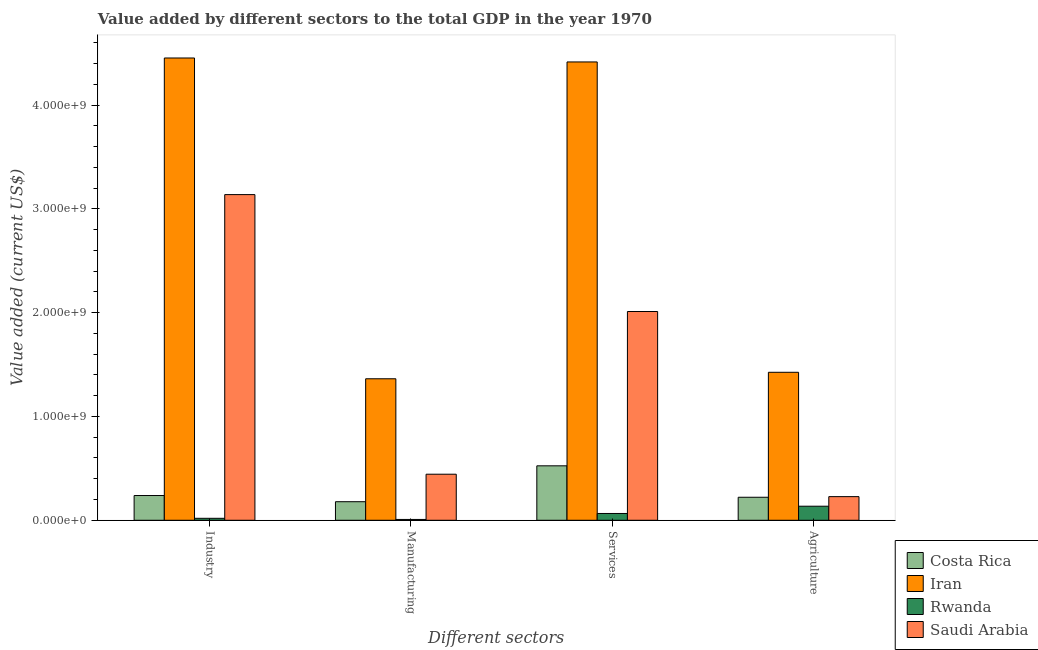How many different coloured bars are there?
Offer a terse response. 4. How many groups of bars are there?
Offer a very short reply. 4. Are the number of bars on each tick of the X-axis equal?
Give a very brief answer. Yes. How many bars are there on the 2nd tick from the left?
Make the answer very short. 4. How many bars are there on the 2nd tick from the right?
Ensure brevity in your answer.  4. What is the label of the 2nd group of bars from the left?
Make the answer very short. Manufacturing. What is the value added by services sector in Iran?
Your answer should be compact. 4.42e+09. Across all countries, what is the maximum value added by agricultural sector?
Your answer should be very brief. 1.43e+09. Across all countries, what is the minimum value added by manufacturing sector?
Ensure brevity in your answer.  7.90e+06. In which country was the value added by industrial sector maximum?
Make the answer very short. Iran. In which country was the value added by manufacturing sector minimum?
Provide a succinct answer. Rwanda. What is the total value added by services sector in the graph?
Offer a very short reply. 7.02e+09. What is the difference between the value added by manufacturing sector in Rwanda and that in Costa Rica?
Your response must be concise. -1.71e+08. What is the difference between the value added by agricultural sector in Costa Rica and the value added by manufacturing sector in Rwanda?
Offer a very short reply. 2.14e+08. What is the average value added by manufacturing sector per country?
Your response must be concise. 4.98e+08. What is the difference between the value added by manufacturing sector and value added by services sector in Costa Rica?
Give a very brief answer. -3.46e+08. In how many countries, is the value added by industrial sector greater than 3800000000 US$?
Give a very brief answer. 1. What is the ratio of the value added by agricultural sector in Costa Rica to that in Iran?
Your response must be concise. 0.16. Is the value added by services sector in Iran less than that in Rwanda?
Ensure brevity in your answer.  No. What is the difference between the highest and the second highest value added by services sector?
Provide a succinct answer. 2.40e+09. What is the difference between the highest and the lowest value added by industrial sector?
Provide a succinct answer. 4.44e+09. In how many countries, is the value added by services sector greater than the average value added by services sector taken over all countries?
Keep it short and to the point. 2. Is it the case that in every country, the sum of the value added by manufacturing sector and value added by industrial sector is greater than the sum of value added by agricultural sector and value added by services sector?
Give a very brief answer. No. What does the 3rd bar from the left in Manufacturing represents?
Keep it short and to the point. Rwanda. What does the 1st bar from the right in Manufacturing represents?
Your response must be concise. Saudi Arabia. How many bars are there?
Your answer should be very brief. 16. What is the difference between two consecutive major ticks on the Y-axis?
Your answer should be compact. 1.00e+09. Does the graph contain any zero values?
Give a very brief answer. No. Does the graph contain grids?
Your answer should be compact. No. How many legend labels are there?
Offer a terse response. 4. How are the legend labels stacked?
Make the answer very short. Vertical. What is the title of the graph?
Make the answer very short. Value added by different sectors to the total GDP in the year 1970. What is the label or title of the X-axis?
Offer a very short reply. Different sectors. What is the label or title of the Y-axis?
Your answer should be very brief. Value added (current US$). What is the Value added (current US$) in Costa Rica in Industry?
Provide a succinct answer. 2.38e+08. What is the Value added (current US$) in Iran in Industry?
Your answer should be very brief. 4.45e+09. What is the Value added (current US$) of Rwanda in Industry?
Provide a succinct answer. 1.89e+07. What is the Value added (current US$) of Saudi Arabia in Industry?
Your answer should be compact. 3.14e+09. What is the Value added (current US$) in Costa Rica in Manufacturing?
Keep it short and to the point. 1.79e+08. What is the Value added (current US$) of Iran in Manufacturing?
Your answer should be very brief. 1.36e+09. What is the Value added (current US$) of Rwanda in Manufacturing?
Give a very brief answer. 7.90e+06. What is the Value added (current US$) of Saudi Arabia in Manufacturing?
Offer a very short reply. 4.44e+08. What is the Value added (current US$) in Costa Rica in Services?
Offer a very short reply. 5.25e+08. What is the Value added (current US$) of Iran in Services?
Make the answer very short. 4.42e+09. What is the Value added (current US$) in Rwanda in Services?
Your answer should be compact. 6.55e+07. What is the Value added (current US$) of Saudi Arabia in Services?
Your answer should be very brief. 2.01e+09. What is the Value added (current US$) of Costa Rica in Agriculture?
Your response must be concise. 2.22e+08. What is the Value added (current US$) of Iran in Agriculture?
Provide a succinct answer. 1.43e+09. What is the Value added (current US$) in Rwanda in Agriculture?
Provide a short and direct response. 1.36e+08. What is the Value added (current US$) of Saudi Arabia in Agriculture?
Keep it short and to the point. 2.28e+08. Across all Different sectors, what is the maximum Value added (current US$) in Costa Rica?
Make the answer very short. 5.25e+08. Across all Different sectors, what is the maximum Value added (current US$) of Iran?
Ensure brevity in your answer.  4.45e+09. Across all Different sectors, what is the maximum Value added (current US$) in Rwanda?
Provide a short and direct response. 1.36e+08. Across all Different sectors, what is the maximum Value added (current US$) of Saudi Arabia?
Your answer should be compact. 3.14e+09. Across all Different sectors, what is the minimum Value added (current US$) in Costa Rica?
Your response must be concise. 1.79e+08. Across all Different sectors, what is the minimum Value added (current US$) of Iran?
Your answer should be very brief. 1.36e+09. Across all Different sectors, what is the minimum Value added (current US$) of Rwanda?
Keep it short and to the point. 7.90e+06. Across all Different sectors, what is the minimum Value added (current US$) of Saudi Arabia?
Your answer should be compact. 2.28e+08. What is the total Value added (current US$) of Costa Rica in the graph?
Your answer should be very brief. 1.16e+09. What is the total Value added (current US$) in Iran in the graph?
Your answer should be very brief. 1.17e+1. What is the total Value added (current US$) in Rwanda in the graph?
Offer a terse response. 2.28e+08. What is the total Value added (current US$) in Saudi Arabia in the graph?
Provide a short and direct response. 5.82e+09. What is the difference between the Value added (current US$) in Costa Rica in Industry and that in Manufacturing?
Your answer should be very brief. 5.95e+07. What is the difference between the Value added (current US$) in Iran in Industry and that in Manufacturing?
Offer a very short reply. 3.09e+09. What is the difference between the Value added (current US$) in Rwanda in Industry and that in Manufacturing?
Offer a terse response. 1.10e+07. What is the difference between the Value added (current US$) of Saudi Arabia in Industry and that in Manufacturing?
Your answer should be very brief. 2.69e+09. What is the difference between the Value added (current US$) in Costa Rica in Industry and that in Services?
Make the answer very short. -2.86e+08. What is the difference between the Value added (current US$) of Iran in Industry and that in Services?
Ensure brevity in your answer.  3.81e+07. What is the difference between the Value added (current US$) of Rwanda in Industry and that in Services?
Your answer should be compact. -4.66e+07. What is the difference between the Value added (current US$) in Saudi Arabia in Industry and that in Services?
Make the answer very short. 1.13e+09. What is the difference between the Value added (current US$) in Costa Rica in Industry and that in Agriculture?
Provide a short and direct response. 1.66e+07. What is the difference between the Value added (current US$) of Iran in Industry and that in Agriculture?
Provide a succinct answer. 3.03e+09. What is the difference between the Value added (current US$) of Rwanda in Industry and that in Agriculture?
Your answer should be compact. -1.17e+08. What is the difference between the Value added (current US$) of Saudi Arabia in Industry and that in Agriculture?
Make the answer very short. 2.91e+09. What is the difference between the Value added (current US$) in Costa Rica in Manufacturing and that in Services?
Make the answer very short. -3.46e+08. What is the difference between the Value added (current US$) in Iran in Manufacturing and that in Services?
Offer a terse response. -3.05e+09. What is the difference between the Value added (current US$) of Rwanda in Manufacturing and that in Services?
Your answer should be very brief. -5.76e+07. What is the difference between the Value added (current US$) in Saudi Arabia in Manufacturing and that in Services?
Provide a short and direct response. -1.57e+09. What is the difference between the Value added (current US$) in Costa Rica in Manufacturing and that in Agriculture?
Provide a short and direct response. -4.29e+07. What is the difference between the Value added (current US$) in Iran in Manufacturing and that in Agriculture?
Provide a short and direct response. -6.25e+07. What is the difference between the Value added (current US$) of Rwanda in Manufacturing and that in Agriculture?
Keep it short and to the point. -1.28e+08. What is the difference between the Value added (current US$) of Saudi Arabia in Manufacturing and that in Agriculture?
Make the answer very short. 2.16e+08. What is the difference between the Value added (current US$) of Costa Rica in Services and that in Agriculture?
Provide a short and direct response. 3.03e+08. What is the difference between the Value added (current US$) of Iran in Services and that in Agriculture?
Give a very brief answer. 2.99e+09. What is the difference between the Value added (current US$) of Rwanda in Services and that in Agriculture?
Keep it short and to the point. -7.00e+07. What is the difference between the Value added (current US$) of Saudi Arabia in Services and that in Agriculture?
Offer a terse response. 1.78e+09. What is the difference between the Value added (current US$) in Costa Rica in Industry and the Value added (current US$) in Iran in Manufacturing?
Ensure brevity in your answer.  -1.12e+09. What is the difference between the Value added (current US$) in Costa Rica in Industry and the Value added (current US$) in Rwanda in Manufacturing?
Offer a very short reply. 2.30e+08. What is the difference between the Value added (current US$) in Costa Rica in Industry and the Value added (current US$) in Saudi Arabia in Manufacturing?
Offer a terse response. -2.05e+08. What is the difference between the Value added (current US$) of Iran in Industry and the Value added (current US$) of Rwanda in Manufacturing?
Make the answer very short. 4.45e+09. What is the difference between the Value added (current US$) of Iran in Industry and the Value added (current US$) of Saudi Arabia in Manufacturing?
Give a very brief answer. 4.01e+09. What is the difference between the Value added (current US$) in Rwanda in Industry and the Value added (current US$) in Saudi Arabia in Manufacturing?
Give a very brief answer. -4.25e+08. What is the difference between the Value added (current US$) in Costa Rica in Industry and the Value added (current US$) in Iran in Services?
Offer a very short reply. -4.18e+09. What is the difference between the Value added (current US$) in Costa Rica in Industry and the Value added (current US$) in Rwanda in Services?
Provide a short and direct response. 1.73e+08. What is the difference between the Value added (current US$) of Costa Rica in Industry and the Value added (current US$) of Saudi Arabia in Services?
Provide a short and direct response. -1.77e+09. What is the difference between the Value added (current US$) in Iran in Industry and the Value added (current US$) in Rwanda in Services?
Make the answer very short. 4.39e+09. What is the difference between the Value added (current US$) of Iran in Industry and the Value added (current US$) of Saudi Arabia in Services?
Keep it short and to the point. 2.44e+09. What is the difference between the Value added (current US$) of Rwanda in Industry and the Value added (current US$) of Saudi Arabia in Services?
Keep it short and to the point. -1.99e+09. What is the difference between the Value added (current US$) of Costa Rica in Industry and the Value added (current US$) of Iran in Agriculture?
Ensure brevity in your answer.  -1.19e+09. What is the difference between the Value added (current US$) of Costa Rica in Industry and the Value added (current US$) of Rwanda in Agriculture?
Provide a succinct answer. 1.03e+08. What is the difference between the Value added (current US$) in Costa Rica in Industry and the Value added (current US$) in Saudi Arabia in Agriculture?
Your answer should be compact. 1.06e+07. What is the difference between the Value added (current US$) in Iran in Industry and the Value added (current US$) in Rwanda in Agriculture?
Offer a very short reply. 4.32e+09. What is the difference between the Value added (current US$) of Iran in Industry and the Value added (current US$) of Saudi Arabia in Agriculture?
Ensure brevity in your answer.  4.23e+09. What is the difference between the Value added (current US$) of Rwanda in Industry and the Value added (current US$) of Saudi Arabia in Agriculture?
Your response must be concise. -2.09e+08. What is the difference between the Value added (current US$) in Costa Rica in Manufacturing and the Value added (current US$) in Iran in Services?
Your answer should be very brief. -4.24e+09. What is the difference between the Value added (current US$) in Costa Rica in Manufacturing and the Value added (current US$) in Rwanda in Services?
Your answer should be very brief. 1.13e+08. What is the difference between the Value added (current US$) of Costa Rica in Manufacturing and the Value added (current US$) of Saudi Arabia in Services?
Your answer should be very brief. -1.83e+09. What is the difference between the Value added (current US$) in Iran in Manufacturing and the Value added (current US$) in Rwanda in Services?
Offer a terse response. 1.30e+09. What is the difference between the Value added (current US$) in Iran in Manufacturing and the Value added (current US$) in Saudi Arabia in Services?
Make the answer very short. -6.48e+08. What is the difference between the Value added (current US$) in Rwanda in Manufacturing and the Value added (current US$) in Saudi Arabia in Services?
Provide a succinct answer. -2.00e+09. What is the difference between the Value added (current US$) in Costa Rica in Manufacturing and the Value added (current US$) in Iran in Agriculture?
Your answer should be very brief. -1.25e+09. What is the difference between the Value added (current US$) in Costa Rica in Manufacturing and the Value added (current US$) in Rwanda in Agriculture?
Make the answer very short. 4.34e+07. What is the difference between the Value added (current US$) of Costa Rica in Manufacturing and the Value added (current US$) of Saudi Arabia in Agriculture?
Provide a succinct answer. -4.89e+07. What is the difference between the Value added (current US$) of Iran in Manufacturing and the Value added (current US$) of Rwanda in Agriculture?
Offer a very short reply. 1.23e+09. What is the difference between the Value added (current US$) in Iran in Manufacturing and the Value added (current US$) in Saudi Arabia in Agriculture?
Make the answer very short. 1.14e+09. What is the difference between the Value added (current US$) in Rwanda in Manufacturing and the Value added (current US$) in Saudi Arabia in Agriculture?
Your response must be concise. -2.20e+08. What is the difference between the Value added (current US$) in Costa Rica in Services and the Value added (current US$) in Iran in Agriculture?
Ensure brevity in your answer.  -9.01e+08. What is the difference between the Value added (current US$) of Costa Rica in Services and the Value added (current US$) of Rwanda in Agriculture?
Make the answer very short. 3.89e+08. What is the difference between the Value added (current US$) of Costa Rica in Services and the Value added (current US$) of Saudi Arabia in Agriculture?
Your answer should be compact. 2.97e+08. What is the difference between the Value added (current US$) in Iran in Services and the Value added (current US$) in Rwanda in Agriculture?
Provide a succinct answer. 4.28e+09. What is the difference between the Value added (current US$) of Iran in Services and the Value added (current US$) of Saudi Arabia in Agriculture?
Make the answer very short. 4.19e+09. What is the difference between the Value added (current US$) of Rwanda in Services and the Value added (current US$) of Saudi Arabia in Agriculture?
Your answer should be very brief. -1.62e+08. What is the average Value added (current US$) of Costa Rica per Different sectors?
Keep it short and to the point. 2.91e+08. What is the average Value added (current US$) in Iran per Different sectors?
Keep it short and to the point. 2.92e+09. What is the average Value added (current US$) in Rwanda per Different sectors?
Keep it short and to the point. 5.70e+07. What is the average Value added (current US$) in Saudi Arabia per Different sectors?
Give a very brief answer. 1.46e+09. What is the difference between the Value added (current US$) in Costa Rica and Value added (current US$) in Iran in Industry?
Give a very brief answer. -4.22e+09. What is the difference between the Value added (current US$) of Costa Rica and Value added (current US$) of Rwanda in Industry?
Your answer should be very brief. 2.19e+08. What is the difference between the Value added (current US$) of Costa Rica and Value added (current US$) of Saudi Arabia in Industry?
Make the answer very short. -2.90e+09. What is the difference between the Value added (current US$) of Iran and Value added (current US$) of Rwanda in Industry?
Provide a short and direct response. 4.44e+09. What is the difference between the Value added (current US$) of Iran and Value added (current US$) of Saudi Arabia in Industry?
Your answer should be compact. 1.32e+09. What is the difference between the Value added (current US$) in Rwanda and Value added (current US$) in Saudi Arabia in Industry?
Your response must be concise. -3.12e+09. What is the difference between the Value added (current US$) of Costa Rica and Value added (current US$) of Iran in Manufacturing?
Give a very brief answer. -1.18e+09. What is the difference between the Value added (current US$) in Costa Rica and Value added (current US$) in Rwanda in Manufacturing?
Give a very brief answer. 1.71e+08. What is the difference between the Value added (current US$) of Costa Rica and Value added (current US$) of Saudi Arabia in Manufacturing?
Keep it short and to the point. -2.65e+08. What is the difference between the Value added (current US$) of Iran and Value added (current US$) of Rwanda in Manufacturing?
Keep it short and to the point. 1.36e+09. What is the difference between the Value added (current US$) of Iran and Value added (current US$) of Saudi Arabia in Manufacturing?
Make the answer very short. 9.20e+08. What is the difference between the Value added (current US$) in Rwanda and Value added (current US$) in Saudi Arabia in Manufacturing?
Provide a short and direct response. -4.36e+08. What is the difference between the Value added (current US$) of Costa Rica and Value added (current US$) of Iran in Services?
Give a very brief answer. -3.89e+09. What is the difference between the Value added (current US$) in Costa Rica and Value added (current US$) in Rwanda in Services?
Your answer should be compact. 4.59e+08. What is the difference between the Value added (current US$) of Costa Rica and Value added (current US$) of Saudi Arabia in Services?
Provide a succinct answer. -1.49e+09. What is the difference between the Value added (current US$) of Iran and Value added (current US$) of Rwanda in Services?
Provide a succinct answer. 4.35e+09. What is the difference between the Value added (current US$) of Iran and Value added (current US$) of Saudi Arabia in Services?
Offer a very short reply. 2.40e+09. What is the difference between the Value added (current US$) of Rwanda and Value added (current US$) of Saudi Arabia in Services?
Give a very brief answer. -1.95e+09. What is the difference between the Value added (current US$) in Costa Rica and Value added (current US$) in Iran in Agriculture?
Offer a very short reply. -1.20e+09. What is the difference between the Value added (current US$) of Costa Rica and Value added (current US$) of Rwanda in Agriculture?
Keep it short and to the point. 8.63e+07. What is the difference between the Value added (current US$) of Costa Rica and Value added (current US$) of Saudi Arabia in Agriculture?
Provide a short and direct response. -6.00e+06. What is the difference between the Value added (current US$) of Iran and Value added (current US$) of Rwanda in Agriculture?
Provide a short and direct response. 1.29e+09. What is the difference between the Value added (current US$) in Iran and Value added (current US$) in Saudi Arabia in Agriculture?
Your answer should be very brief. 1.20e+09. What is the difference between the Value added (current US$) of Rwanda and Value added (current US$) of Saudi Arabia in Agriculture?
Ensure brevity in your answer.  -9.23e+07. What is the ratio of the Value added (current US$) of Costa Rica in Industry to that in Manufacturing?
Your answer should be very brief. 1.33. What is the ratio of the Value added (current US$) in Iran in Industry to that in Manufacturing?
Your answer should be compact. 3.27. What is the ratio of the Value added (current US$) in Rwanda in Industry to that in Manufacturing?
Provide a short and direct response. 2.39. What is the ratio of the Value added (current US$) of Saudi Arabia in Industry to that in Manufacturing?
Make the answer very short. 7.07. What is the ratio of the Value added (current US$) in Costa Rica in Industry to that in Services?
Give a very brief answer. 0.45. What is the ratio of the Value added (current US$) in Iran in Industry to that in Services?
Offer a terse response. 1.01. What is the ratio of the Value added (current US$) in Rwanda in Industry to that in Services?
Your answer should be compact. 0.29. What is the ratio of the Value added (current US$) of Saudi Arabia in Industry to that in Services?
Your response must be concise. 1.56. What is the ratio of the Value added (current US$) in Costa Rica in Industry to that in Agriculture?
Offer a very short reply. 1.07. What is the ratio of the Value added (current US$) in Iran in Industry to that in Agriculture?
Give a very brief answer. 3.12. What is the ratio of the Value added (current US$) of Rwanda in Industry to that in Agriculture?
Your answer should be very brief. 0.14. What is the ratio of the Value added (current US$) in Saudi Arabia in Industry to that in Agriculture?
Your answer should be very brief. 13.78. What is the ratio of the Value added (current US$) of Costa Rica in Manufacturing to that in Services?
Your response must be concise. 0.34. What is the ratio of the Value added (current US$) in Iran in Manufacturing to that in Services?
Offer a very short reply. 0.31. What is the ratio of the Value added (current US$) of Rwanda in Manufacturing to that in Services?
Provide a succinct answer. 0.12. What is the ratio of the Value added (current US$) of Saudi Arabia in Manufacturing to that in Services?
Offer a very short reply. 0.22. What is the ratio of the Value added (current US$) of Costa Rica in Manufacturing to that in Agriculture?
Ensure brevity in your answer.  0.81. What is the ratio of the Value added (current US$) in Iran in Manufacturing to that in Agriculture?
Keep it short and to the point. 0.96. What is the ratio of the Value added (current US$) of Rwanda in Manufacturing to that in Agriculture?
Make the answer very short. 0.06. What is the ratio of the Value added (current US$) in Saudi Arabia in Manufacturing to that in Agriculture?
Make the answer very short. 1.95. What is the ratio of the Value added (current US$) of Costa Rica in Services to that in Agriculture?
Make the answer very short. 2.37. What is the ratio of the Value added (current US$) in Iran in Services to that in Agriculture?
Your answer should be compact. 3.1. What is the ratio of the Value added (current US$) of Rwanda in Services to that in Agriculture?
Offer a terse response. 0.48. What is the ratio of the Value added (current US$) of Saudi Arabia in Services to that in Agriculture?
Ensure brevity in your answer.  8.83. What is the difference between the highest and the second highest Value added (current US$) in Costa Rica?
Your answer should be very brief. 2.86e+08. What is the difference between the highest and the second highest Value added (current US$) in Iran?
Ensure brevity in your answer.  3.81e+07. What is the difference between the highest and the second highest Value added (current US$) of Rwanda?
Provide a short and direct response. 7.00e+07. What is the difference between the highest and the second highest Value added (current US$) of Saudi Arabia?
Your answer should be compact. 1.13e+09. What is the difference between the highest and the lowest Value added (current US$) of Costa Rica?
Make the answer very short. 3.46e+08. What is the difference between the highest and the lowest Value added (current US$) of Iran?
Your answer should be compact. 3.09e+09. What is the difference between the highest and the lowest Value added (current US$) of Rwanda?
Provide a succinct answer. 1.28e+08. What is the difference between the highest and the lowest Value added (current US$) in Saudi Arabia?
Your answer should be very brief. 2.91e+09. 